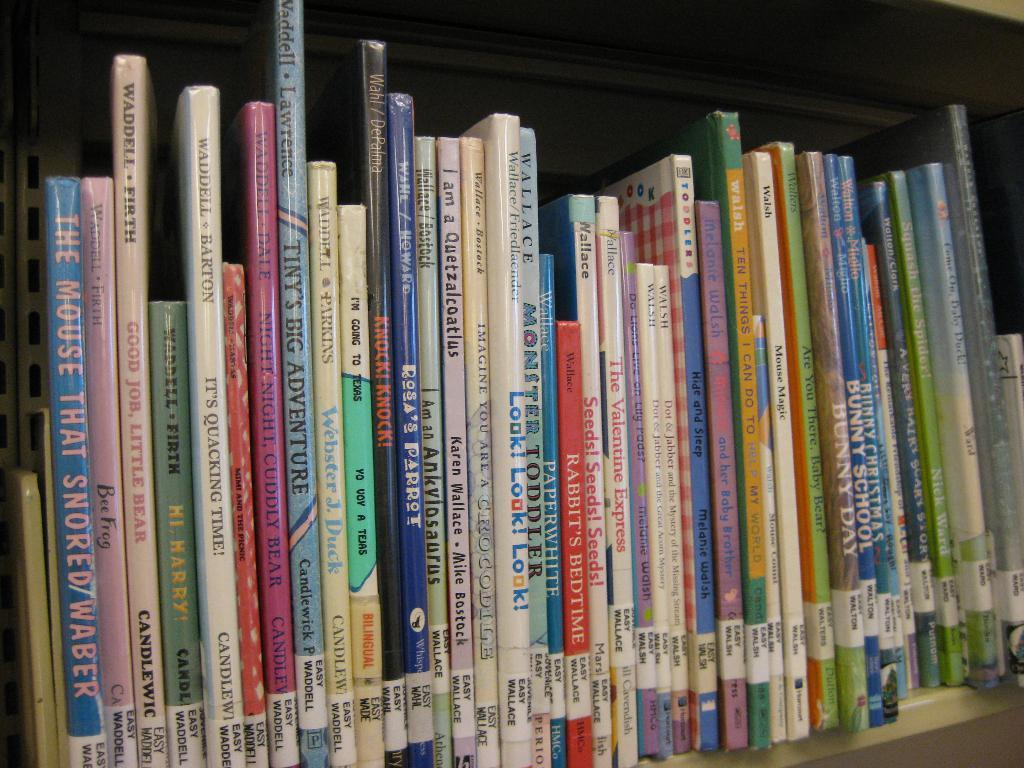<image>
Give a short and clear explanation of the subsequent image. the word mouse is on the blue book 